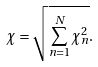<formula> <loc_0><loc_0><loc_500><loc_500>\chi = \sqrt { \overset { N } { \underset { n = 1 } { \sum } } \chi _ { n } ^ { 2 } } .</formula> 